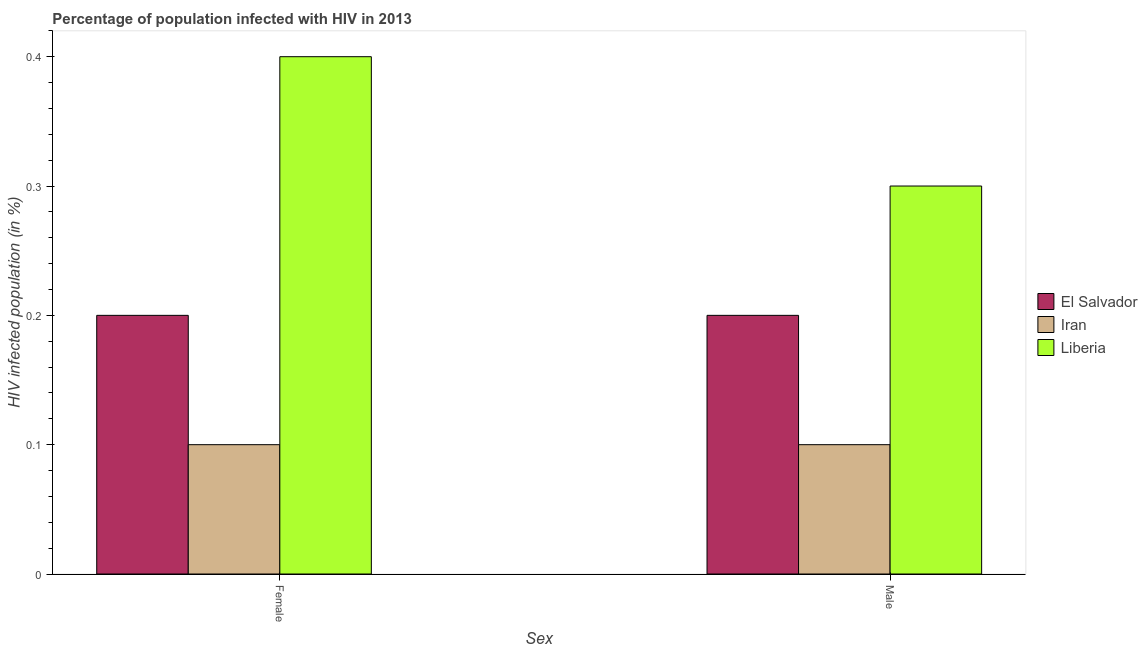Are the number of bars per tick equal to the number of legend labels?
Ensure brevity in your answer.  Yes. Are the number of bars on each tick of the X-axis equal?
Your answer should be very brief. Yes. What is the label of the 1st group of bars from the left?
Offer a terse response. Female. Across all countries, what is the maximum percentage of females who are infected with hiv?
Make the answer very short. 0.4. In which country was the percentage of males who are infected with hiv maximum?
Keep it short and to the point. Liberia. In which country was the percentage of females who are infected with hiv minimum?
Ensure brevity in your answer.  Iran. What is the total percentage of females who are infected with hiv in the graph?
Ensure brevity in your answer.  0.7. What is the difference between the percentage of females who are infected with hiv in Liberia and that in El Salvador?
Give a very brief answer. 0.2. What is the difference between the percentage of females who are infected with hiv in Liberia and the percentage of males who are infected with hiv in Iran?
Offer a terse response. 0.3. What is the average percentage of females who are infected with hiv per country?
Offer a terse response. 0.23. What is the difference between the percentage of females who are infected with hiv and percentage of males who are infected with hiv in El Salvador?
Give a very brief answer. 0. What is the ratio of the percentage of males who are infected with hiv in El Salvador to that in Liberia?
Keep it short and to the point. 0.67. Is the percentage of males who are infected with hiv in El Salvador less than that in Iran?
Your response must be concise. No. What does the 3rd bar from the left in Male represents?
Make the answer very short. Liberia. What does the 2nd bar from the right in Female represents?
Offer a terse response. Iran. Are all the bars in the graph horizontal?
Give a very brief answer. No. What is the difference between two consecutive major ticks on the Y-axis?
Offer a very short reply. 0.1. Where does the legend appear in the graph?
Your answer should be compact. Center right. What is the title of the graph?
Your response must be concise. Percentage of population infected with HIV in 2013. Does "Sub-Saharan Africa (all income levels)" appear as one of the legend labels in the graph?
Your answer should be very brief. No. What is the label or title of the X-axis?
Make the answer very short. Sex. What is the label or title of the Y-axis?
Provide a succinct answer. HIV infected population (in %). What is the HIV infected population (in %) in El Salvador in Male?
Provide a short and direct response. 0.2. What is the HIV infected population (in %) of Iran in Male?
Offer a very short reply. 0.1. Across all Sex, what is the maximum HIV infected population (in %) of El Salvador?
Offer a very short reply. 0.2. Across all Sex, what is the minimum HIV infected population (in %) in Liberia?
Make the answer very short. 0.3. What is the total HIV infected population (in %) of Iran in the graph?
Provide a short and direct response. 0.2. What is the total HIV infected population (in %) of Liberia in the graph?
Provide a short and direct response. 0.7. What is the difference between the HIV infected population (in %) in El Salvador in Female and that in Male?
Keep it short and to the point. 0. What is the difference between the HIV infected population (in %) of El Salvador in Female and the HIV infected population (in %) of Iran in Male?
Give a very brief answer. 0.1. What is the difference between the HIV infected population (in %) in El Salvador in Female and the HIV infected population (in %) in Liberia in Male?
Offer a very short reply. -0.1. What is the difference between the HIV infected population (in %) of El Salvador and HIV infected population (in %) of Iran in Female?
Your answer should be very brief. 0.1. What is the difference between the HIV infected population (in %) of El Salvador and HIV infected population (in %) of Liberia in Female?
Give a very brief answer. -0.2. What is the difference between the HIV infected population (in %) of Iran and HIV infected population (in %) of Liberia in Female?
Keep it short and to the point. -0.3. What is the difference between the HIV infected population (in %) in Iran and HIV infected population (in %) in Liberia in Male?
Keep it short and to the point. -0.2. What is the difference between the highest and the second highest HIV infected population (in %) of El Salvador?
Make the answer very short. 0. What is the difference between the highest and the second highest HIV infected population (in %) in Liberia?
Provide a succinct answer. 0.1. What is the difference between the highest and the lowest HIV infected population (in %) of El Salvador?
Make the answer very short. 0. What is the difference between the highest and the lowest HIV infected population (in %) in Liberia?
Offer a very short reply. 0.1. 